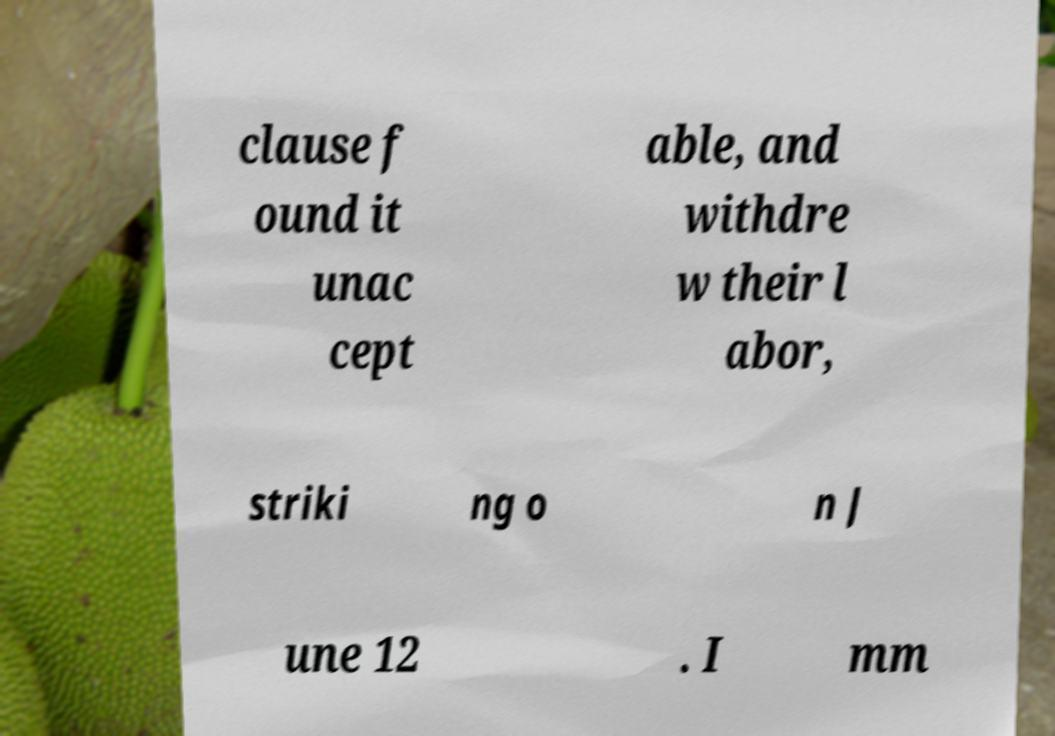Can you accurately transcribe the text from the provided image for me? clause f ound it unac cept able, and withdre w their l abor, striki ng o n J une 12 . I mm 